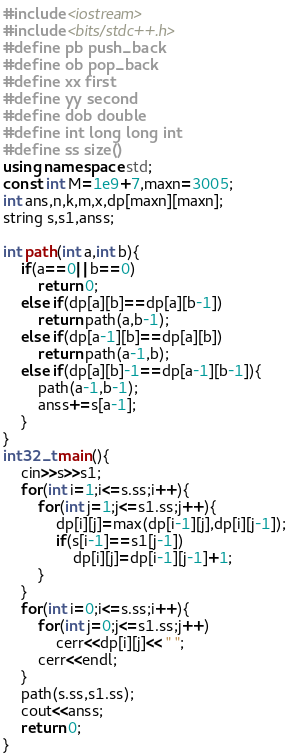<code> <loc_0><loc_0><loc_500><loc_500><_C++_>#include <iostream>
#include <bits/stdc++.h>
#define pb push_back
#define ob pop_back
#define xx first
#define yy second
#define dob double
#define int long long int
#define ss size()
using namespace std;
const int M=1e9+7,maxn=3005;
int ans,n,k,m,x,dp[maxn][maxn];
string s,s1,anss;

int path(int a,int b){
    if(a==0||b==0)
        return 0;
    else if(dp[a][b]==dp[a][b-1])
        return path(a,b-1);
    else if(dp[a-1][b]==dp[a][b])
        return path(a-1,b);
    else if(dp[a][b]-1==dp[a-1][b-1]){
        path(a-1,b-1);
        anss+=s[a-1];
    }
}
int32_t main(){
    cin>>s>>s1;
    for(int i=1;i<=s.ss;i++){
        for(int j=1;j<=s1.ss;j++){
            dp[i][j]=max(dp[i-1][j],dp[i][j-1]);
            if(s[i-1]==s1[j-1])
                dp[i][j]=dp[i-1][j-1]+1;
        }
    }
    for(int i=0;i<=s.ss;i++){
        for(int j=0;j<=s1.ss;j++)
            cerr<<dp[i][j]<< " ";
        cerr<<endl;
    }
    path(s.ss,s1.ss);
    cout<<anss;
    return 0;
}
</code> 